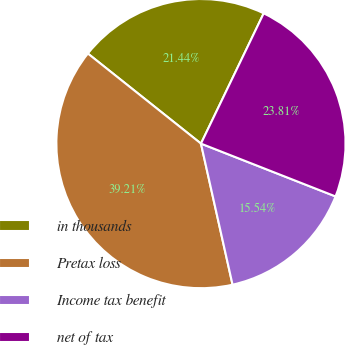<chart> <loc_0><loc_0><loc_500><loc_500><pie_chart><fcel>in thousands<fcel>Pretax loss<fcel>Income tax benefit<fcel>net of tax<nl><fcel>21.44%<fcel>39.21%<fcel>15.54%<fcel>23.81%<nl></chart> 